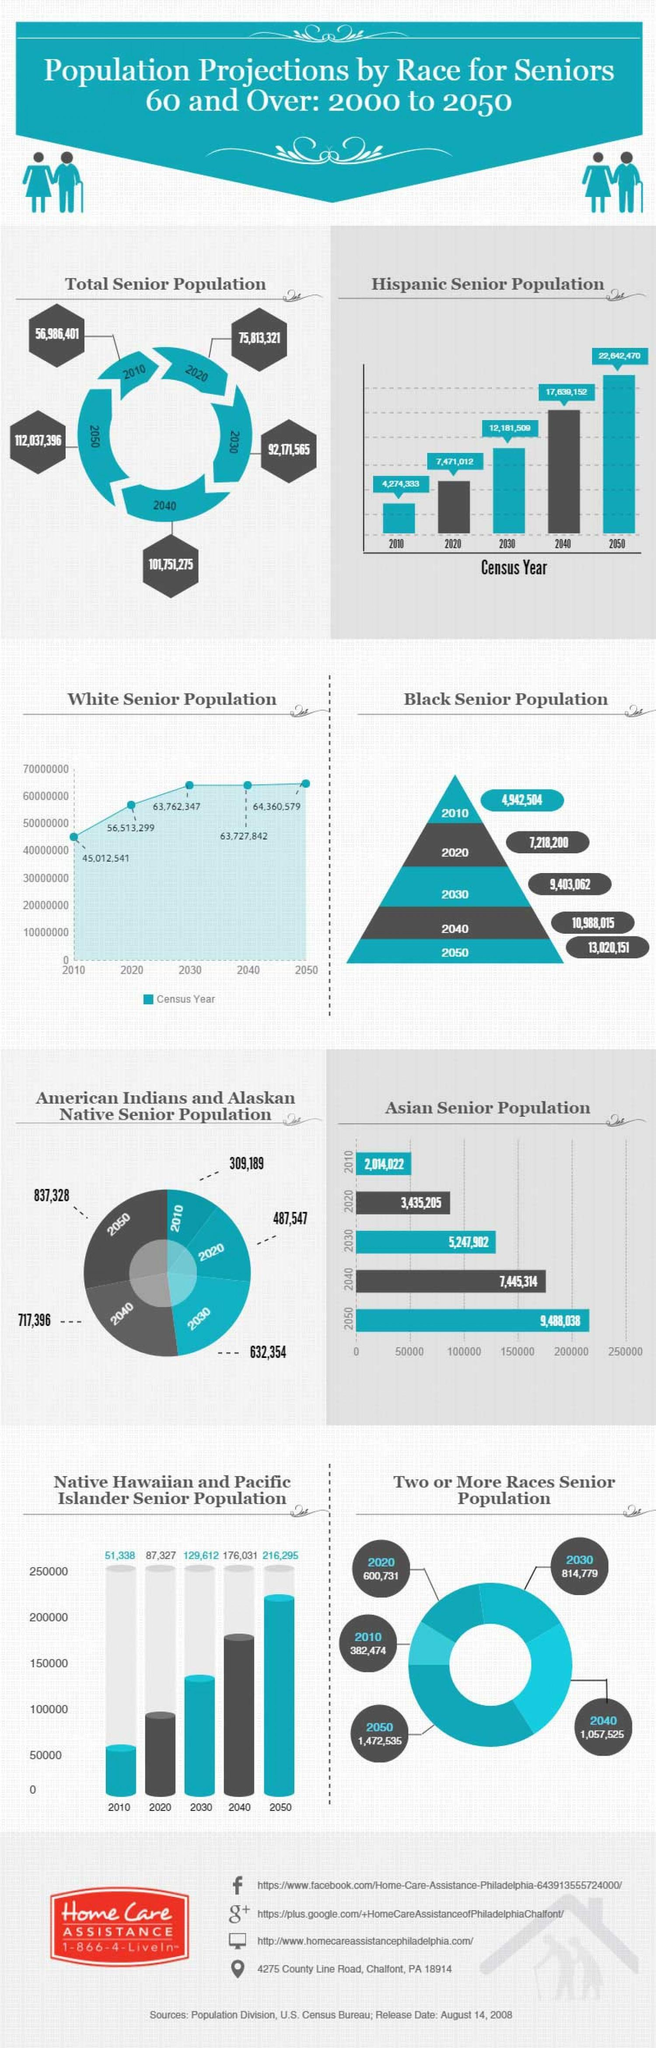What is the difference between the White senior population in 2020 and 2010?
Answer the question with a short phrase. 11,500,758 What is the difference between the Asian senior population in 2040 and 2030? 2,197,412 What is the difference between the Hispanic senior population in 2020 and 2010? 3,196,679 What is the difference between the total senior population in 2050 and 2040? 10,286,121 What is the difference between the Black senior population in 2040 and 2030? 1,584,953 